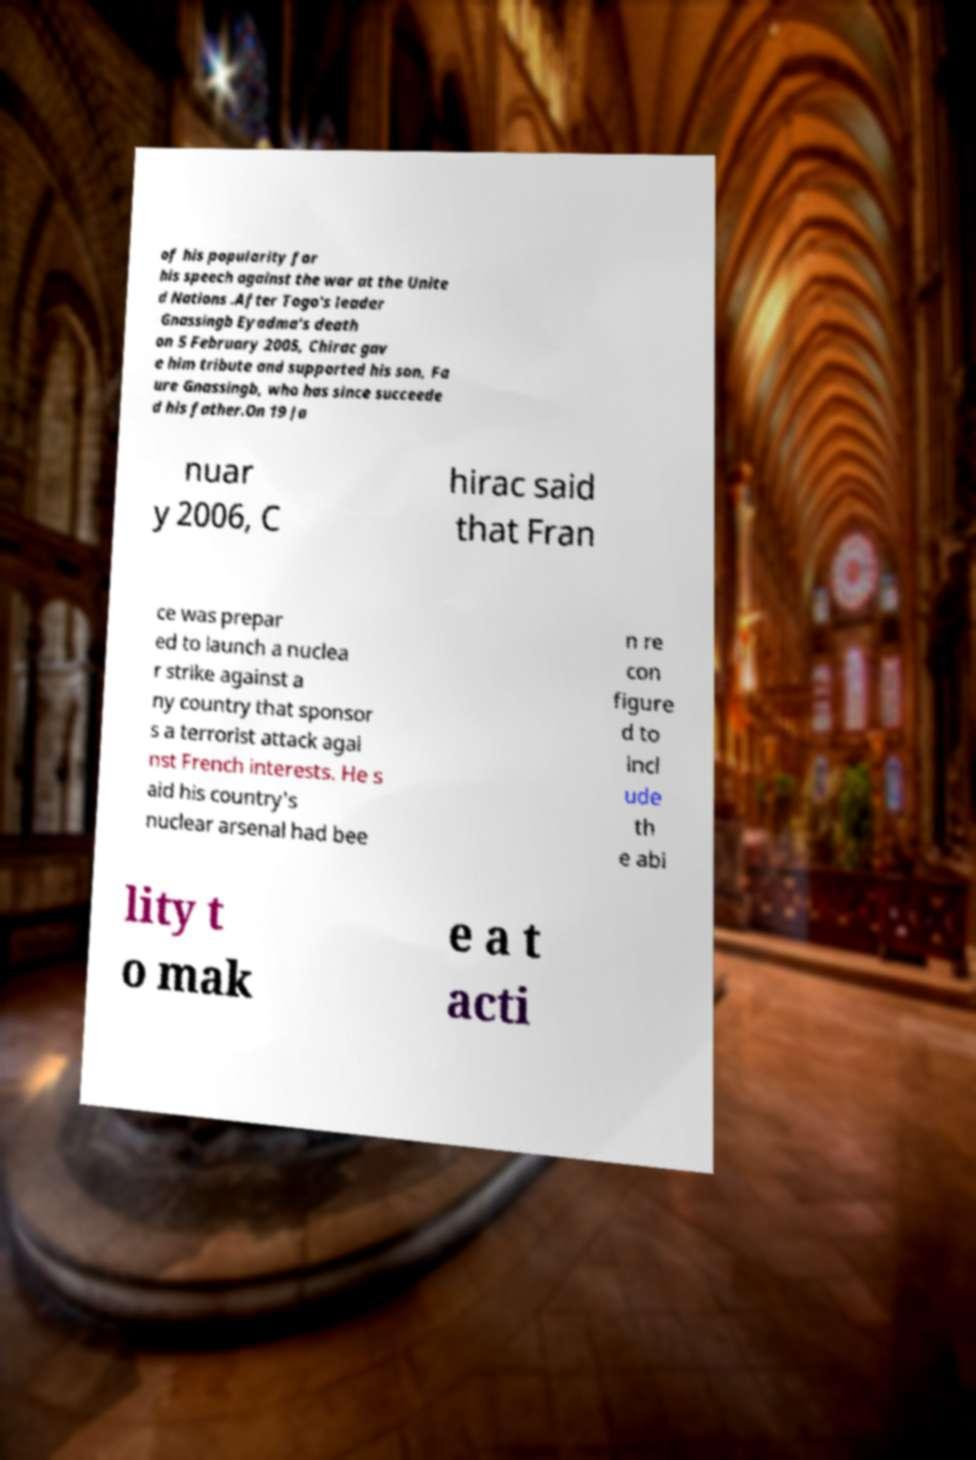Can you read and provide the text displayed in the image?This photo seems to have some interesting text. Can you extract and type it out for me? of his popularity for his speech against the war at the Unite d Nations .After Togo's leader Gnassingb Eyadma's death on 5 February 2005, Chirac gav e him tribute and supported his son, Fa ure Gnassingb, who has since succeede d his father.On 19 Ja nuar y 2006, C hirac said that Fran ce was prepar ed to launch a nuclea r strike against a ny country that sponsor s a terrorist attack agai nst French interests. He s aid his country's nuclear arsenal had bee n re con figure d to incl ude th e abi lity t o mak e a t acti 